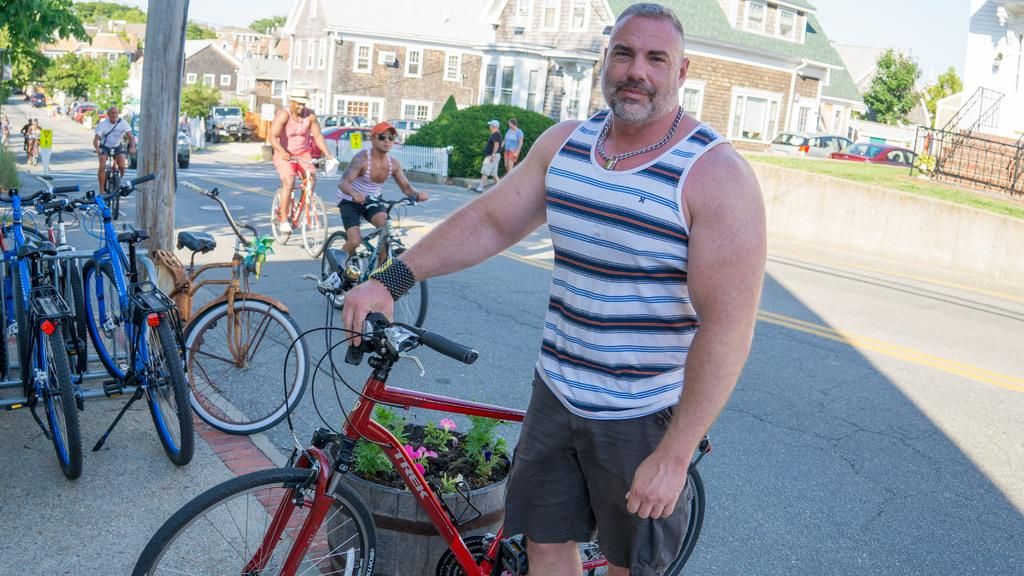What is the man in the image doing? The man is standing in the image and holding a bicycle. Can you describe any other objects or living organisms in the image? Yes, there is a plant in the image. What is happening in the background of the image? In the background, there are people riding bicycles, a tree, a building, and the sky is visible. What type of grip does the writer have on the monkey in the image? There is no writer or monkey present in the image. 